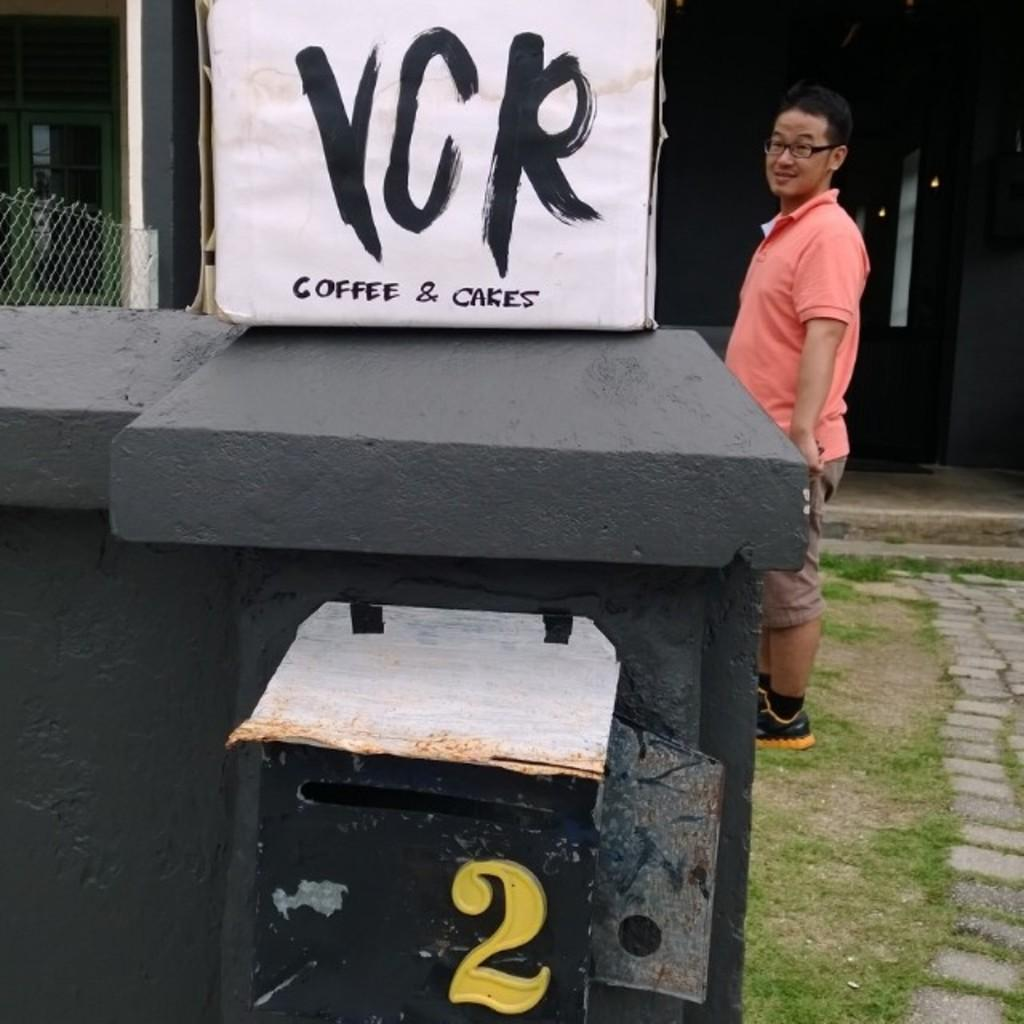What is the main subject in the image? There is a man standing in the image. What can be seen on the platform in the image? There is a board on a platform in the image. What object is present in the image that is typically used for storage? There is a box in the image. What type of material is visible in the image that has small openings? There is mesh in the image. What type of vegetation is visible in the image? There is grass visible in the image. What is the color of the background in the image? The background of the image is dark. What architectural feature can be seen in the background of the image? There is a glass window in the background of the image. What direction is the watch pointing to in the image? There is no watch present in the image, so it cannot be determined which direction it would be pointing. 